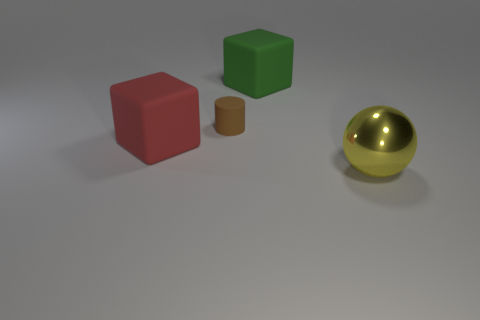What materials do these objects appear to be made of? The red and green objects have a matte finish, suggesting a plastic or painted wood material. The brown object appears to be a cardboard or paper material due to its non-reflective, fibrous texture. The gold object's reflective surface indicates it could be made of polished metal.  Are any of these objects transparent or translucent? No, all the objects in the image are opaque, which means no light passes through them, and thus, they are neither transparent nor translucent. 